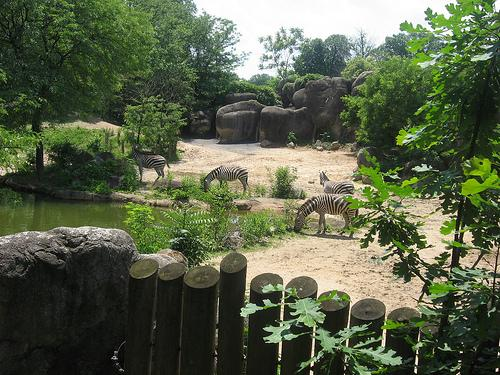Write a summary of the image including the primary subjects and their surroundings. In an outdoor zoo setting, zebras and giraffes roam and graze by a pond, surrounded by trees, bushes, fences, logs, and rocks. Mention the two types of animals found in the image and their respective locations. Zebras are near the edge of the pond, and giraffes are around various parts of the zoo enclosure. Provide a brief description of the main elements in the image. Zebras are grazing near a pond, with a giraffe and a row of logs, rocks forming a barrier, and a wooden fence in the backdrop. Give a concise description of the key aspects in the image related to its setting. A zoo enclosure houses zebras and giraffes by a pond with fences, logs, and a rocky wall creating the borders. Write a short sentence about the environment displayed in the image. In a serene zoo enclosure, zebras and giraffes share a grassy landscape near the water's edge. Describe the boundaries and barriers in the image. A row of logs and rocks act as barriers, along with wooden fence posts and a rocky wall behind the animals. Write a sentence about the trees and vegetation in the image. There's a large tree beside the water, among bushes and varied growth near the pond's edge. Describe the objects that serve as boundaries in the image. Wooden fence posts, rocks, logs, and a rock wall constitute barriers in the animal enclosure. Talk about the surface and ground elements in the picture. The flat dirt covers the zebra enclosure, with cut logs in the scene showing a flat and round surface. Mention the key animals spotted in the image and their actions. Zebras are standing and grazing near the pond, while giraffes graze around the area in the zoo. 